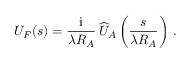Convert formula to latex. <formula><loc_0><loc_0><loc_500><loc_500>U _ { F } ( \boldsymbol s ) = { \frac { i } { \lambda R _ { A } } } \, \widehat { U } _ { A } \left ( { \frac { \boldsymbol s } { \lambda R _ { A } } } \right ) \, .</formula> 